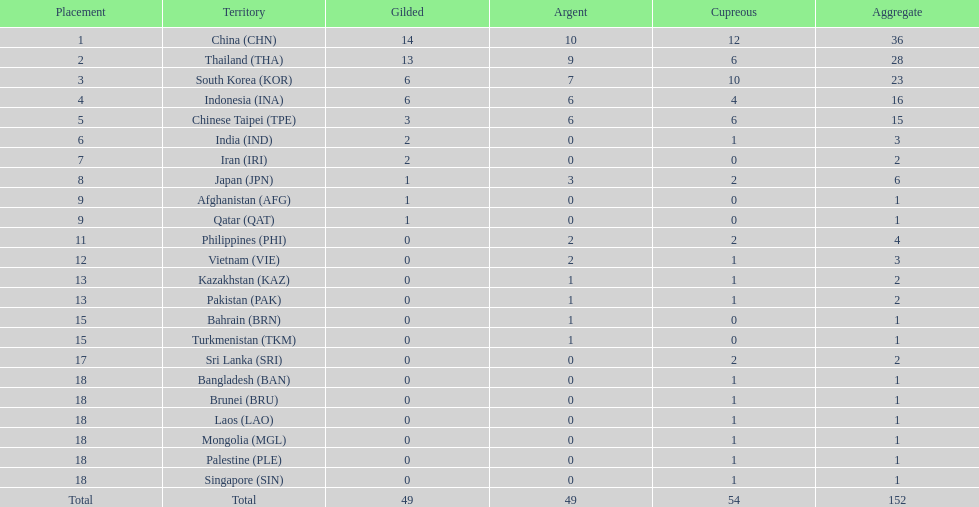Could you help me parse every detail presented in this table? {'header': ['Placement', 'Territory', 'Gilded', 'Argent', 'Cupreous', 'Aggregate'], 'rows': [['1', 'China\xa0(CHN)', '14', '10', '12', '36'], ['2', 'Thailand\xa0(THA)', '13', '9', '6', '28'], ['3', 'South Korea\xa0(KOR)', '6', '7', '10', '23'], ['4', 'Indonesia\xa0(INA)', '6', '6', '4', '16'], ['5', 'Chinese Taipei\xa0(TPE)', '3', '6', '6', '15'], ['6', 'India\xa0(IND)', '2', '0', '1', '3'], ['7', 'Iran\xa0(IRI)', '2', '0', '0', '2'], ['8', 'Japan\xa0(JPN)', '1', '3', '2', '6'], ['9', 'Afghanistan\xa0(AFG)', '1', '0', '0', '1'], ['9', 'Qatar\xa0(QAT)', '1', '0', '0', '1'], ['11', 'Philippines\xa0(PHI)', '0', '2', '2', '4'], ['12', 'Vietnam\xa0(VIE)', '0', '2', '1', '3'], ['13', 'Kazakhstan\xa0(KAZ)', '0', '1', '1', '2'], ['13', 'Pakistan\xa0(PAK)', '0', '1', '1', '2'], ['15', 'Bahrain\xa0(BRN)', '0', '1', '0', '1'], ['15', 'Turkmenistan\xa0(TKM)', '0', '1', '0', '1'], ['17', 'Sri Lanka\xa0(SRI)', '0', '0', '2', '2'], ['18', 'Bangladesh\xa0(BAN)', '0', '0', '1', '1'], ['18', 'Brunei\xa0(BRU)', '0', '0', '1', '1'], ['18', 'Laos\xa0(LAO)', '0', '0', '1', '1'], ['18', 'Mongolia\xa0(MGL)', '0', '0', '1', '1'], ['18', 'Palestine\xa0(PLE)', '0', '0', '1', '1'], ['18', 'Singapore\xa0(SIN)', '0', '0', '1', '1'], ['Total', 'Total', '49', '49', '54', '152']]} How many combined silver medals did china, india, and japan earn ? 13. 